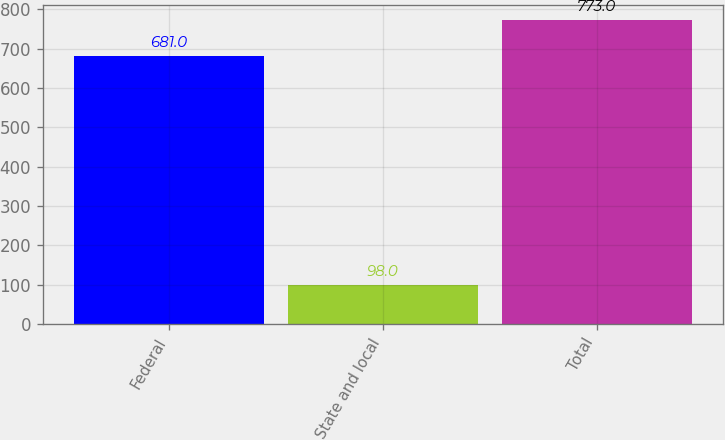<chart> <loc_0><loc_0><loc_500><loc_500><bar_chart><fcel>Federal<fcel>State and local<fcel>Total<nl><fcel>681<fcel>98<fcel>773<nl></chart> 